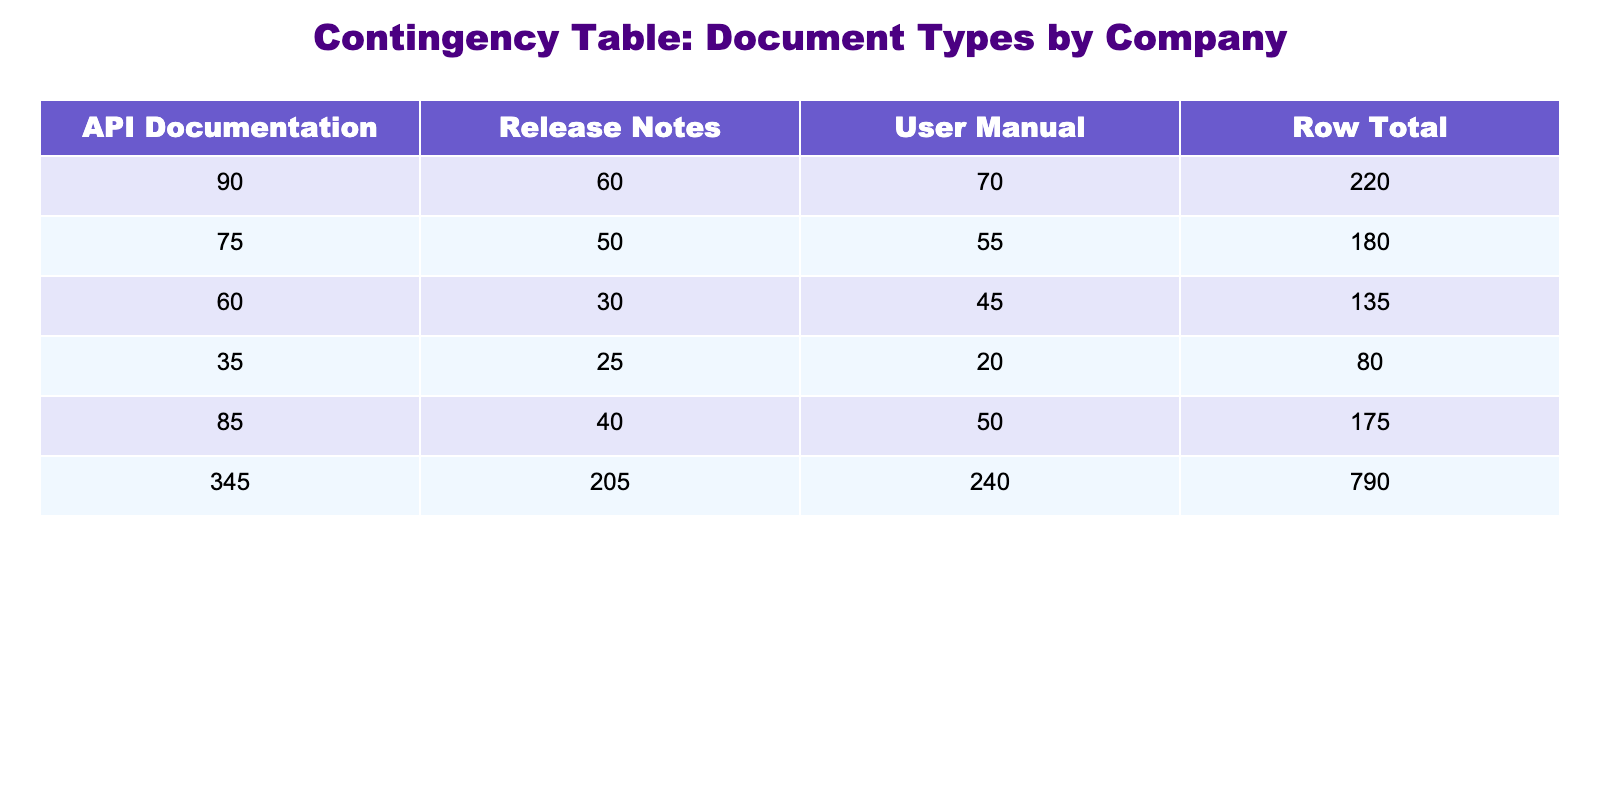What is the frequency of API documentation for Amazon? According to the table, the frequency of API documentation specifically for Amazon is listed as 90.
Answer: 90 Which company has the highest frequency for User Manuals? By examining the User Manual frequencies across all companies, Amazon has the frequency of 70, which is the highest compared to other companies listed (Google: 45, Microsoft: 50, IBM: 20, Apple: 55).
Answer: Amazon What is the total frequency of Release Notes across all companies? To find the total frequency of Release Notes, we add the frequencies: 30 (Google) + 40 (Microsoft) + 25 (IBM) + 60 (Amazon) + 50 (Apple) = 205.
Answer: 205 Is it true that Microsoft has a higher frequency of API Documentation than Google? Looking at the frequencies, Microsoft has an API Documentation frequency of 85, while Google has a frequency of 60. Since 85 is greater than 60, the statement is true.
Answer: Yes What is the average frequency of User Manuals across all companies? To calculate the average frequency of User Manuals, first sum the frequencies: 45 (Google) + 50 (Microsoft) + 20 (IBM) + 70 (Amazon) + 55 (Apple) = 240. There are 5 companies, so the average is 240 / 5 = 48.
Answer: 48 Which document type had the least frequency for IBM? The document types for IBM are User Manual (20), API Documentation (35), and Release Notes (25). The lowest frequency among these is the User Manual with a frequency of 20.
Answer: User Manual What is the difference between the highest frequency of API Documentation and the lowest frequency of Release Notes? The highest frequency of API Documentation is 90 (Amazon), and the lowest frequency of Release Notes is 25 (IBM). The difference is calculated as 90 - 25 = 65.
Answer: 65 Does Apple have a frequency of User Manuals that is greater than 50? From the table, Apple's frequency for User Manuals is 55, which is indeed greater than 50. Therefore, the answer is yes.
Answer: Yes If we sum all frequencies for Google, what is the total? Google has frequencies of 45 (User Manual), 60 (API Documentation), and 30 (Release Notes). Summing these gives 45 + 60 + 30 = 135.
Answer: 135 